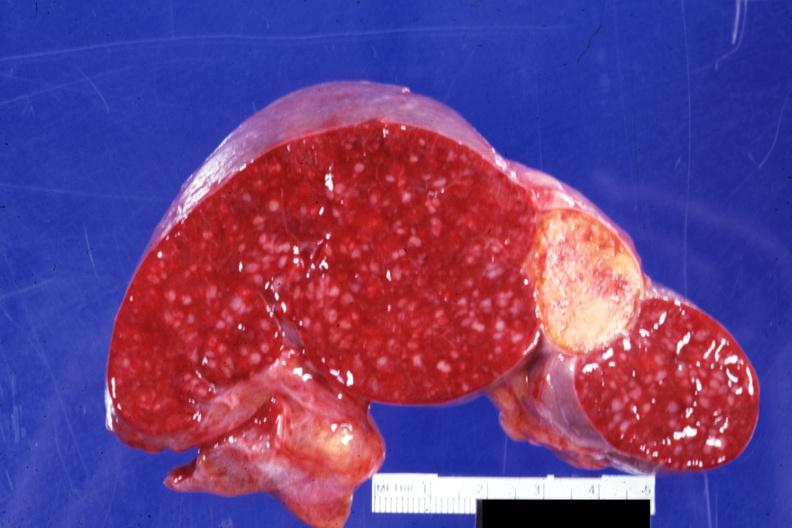what is present?
Answer the question using a single word or phrase. Hematologic 